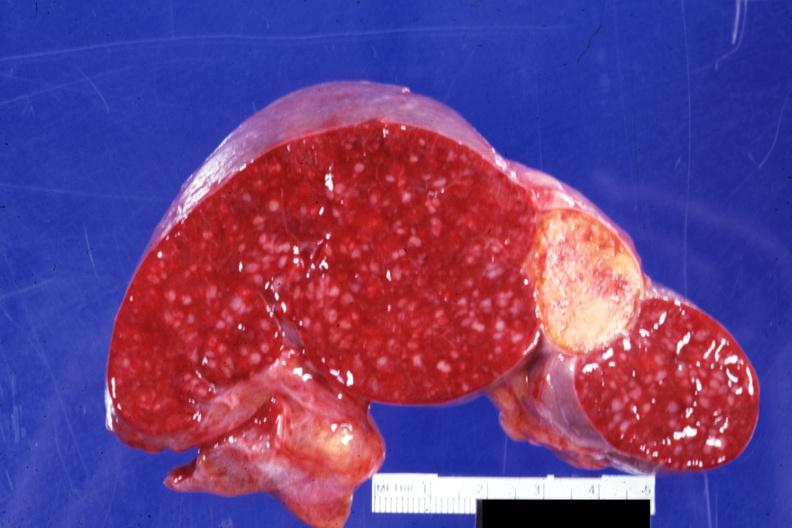what is present?
Answer the question using a single word or phrase. Hematologic 